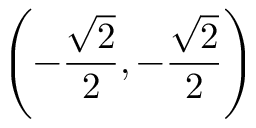<formula> <loc_0><loc_0><loc_500><loc_500>\left ( - { \frac { \sqrt { 2 } } { 2 } } , - { \frac { \sqrt { 2 } } { 2 } } \right )</formula> 